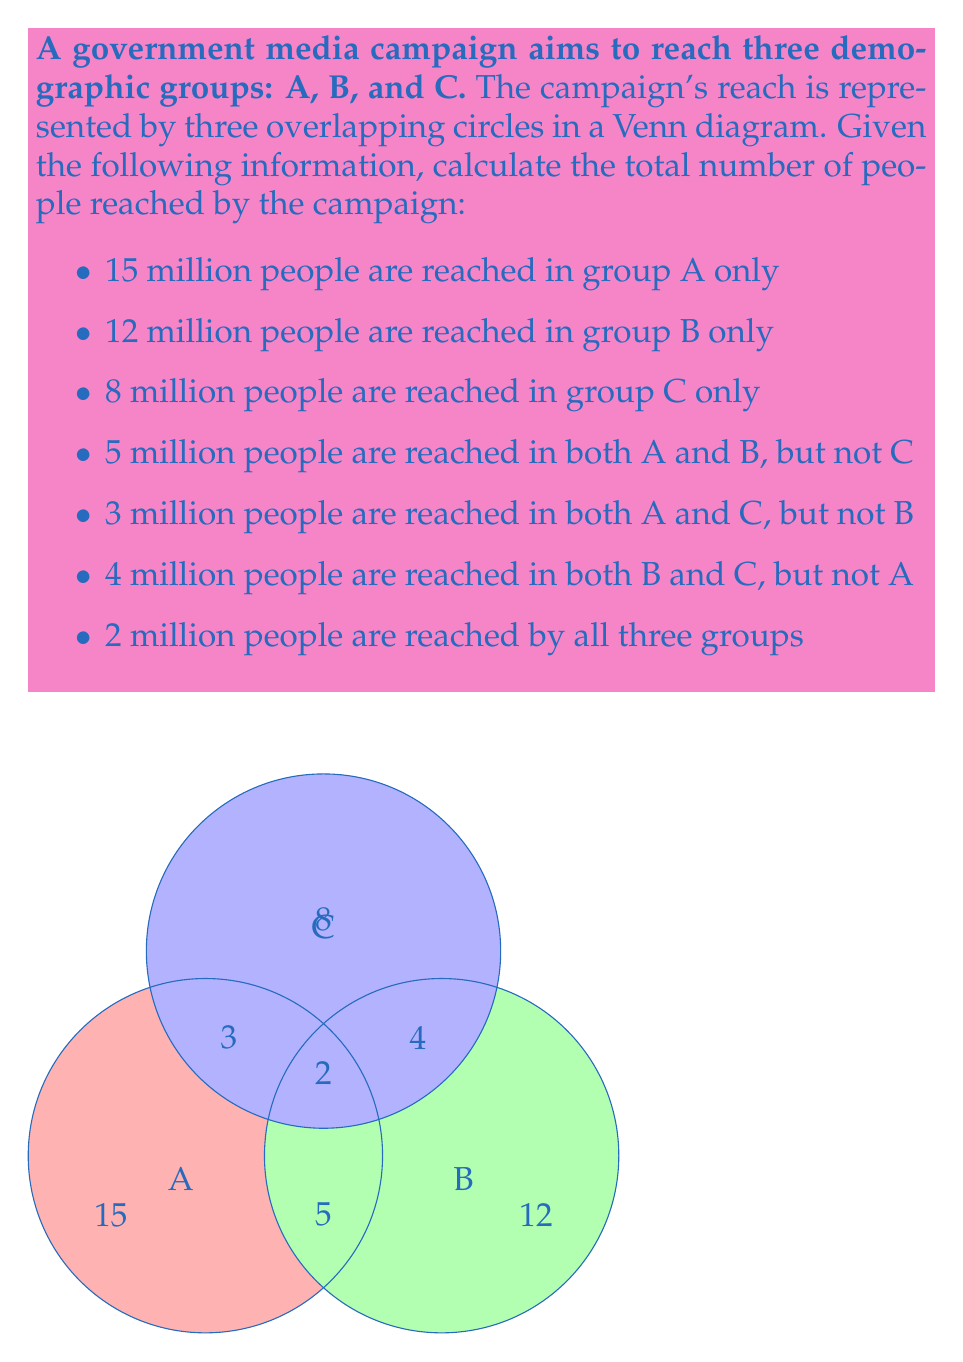Provide a solution to this math problem. To calculate the total number of people reached by the campaign, we need to sum up all the non-overlapping regions in the Venn diagram. Let's break it down step by step:

1. People reached by only one group:
   $A_{only} = 15$ million
   $B_{only} = 12$ million
   $C_{only} = 8$ million

2. People reached by exactly two groups:
   $A \cap B = 5$ million
   $A \cap C = 3$ million
   $B \cap C = 4$ million

3. People reached by all three groups:
   $A \cap B \cap C = 2$ million

Now, let's sum up all these values:

$$\text{Total} = A_{only} + B_{only} + C_{only} + (A \cap B) + (A \cap C) + (B \cap C) + (A \cap B \cap C)$$

Substituting the values:

$$\text{Total} = 15 + 12 + 8 + 5 + 3 + 4 + 2$$

$$\text{Total} = 49 \text{ million}$$

Therefore, the total number of people reached by the campaign is 49 million.
Answer: 49 million 